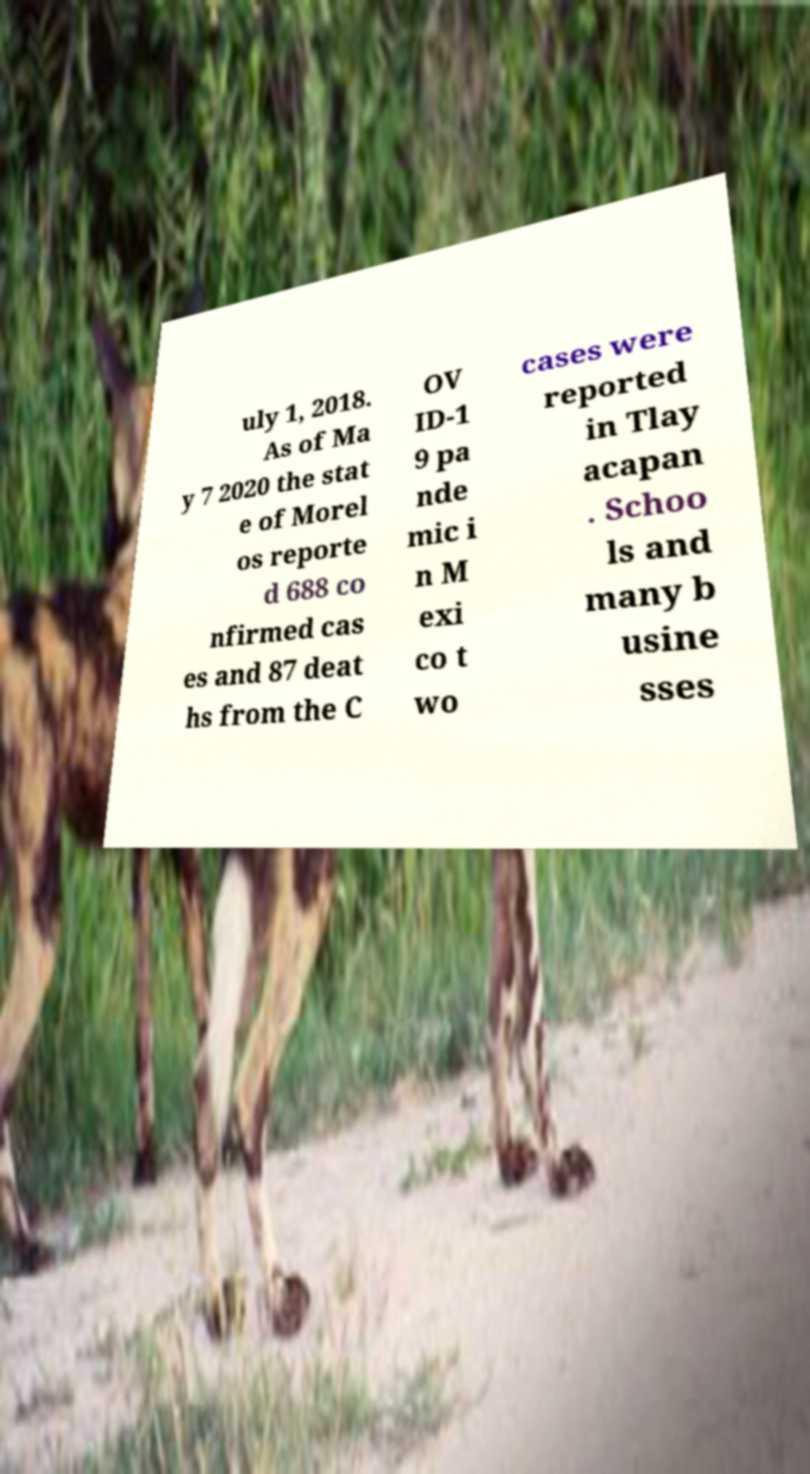Can you read and provide the text displayed in the image?This photo seems to have some interesting text. Can you extract and type it out for me? uly 1, 2018. As of Ma y 7 2020 the stat e of Morel os reporte d 688 co nfirmed cas es and 87 deat hs from the C OV ID-1 9 pa nde mic i n M exi co t wo cases were reported in Tlay acapan . Schoo ls and many b usine sses 